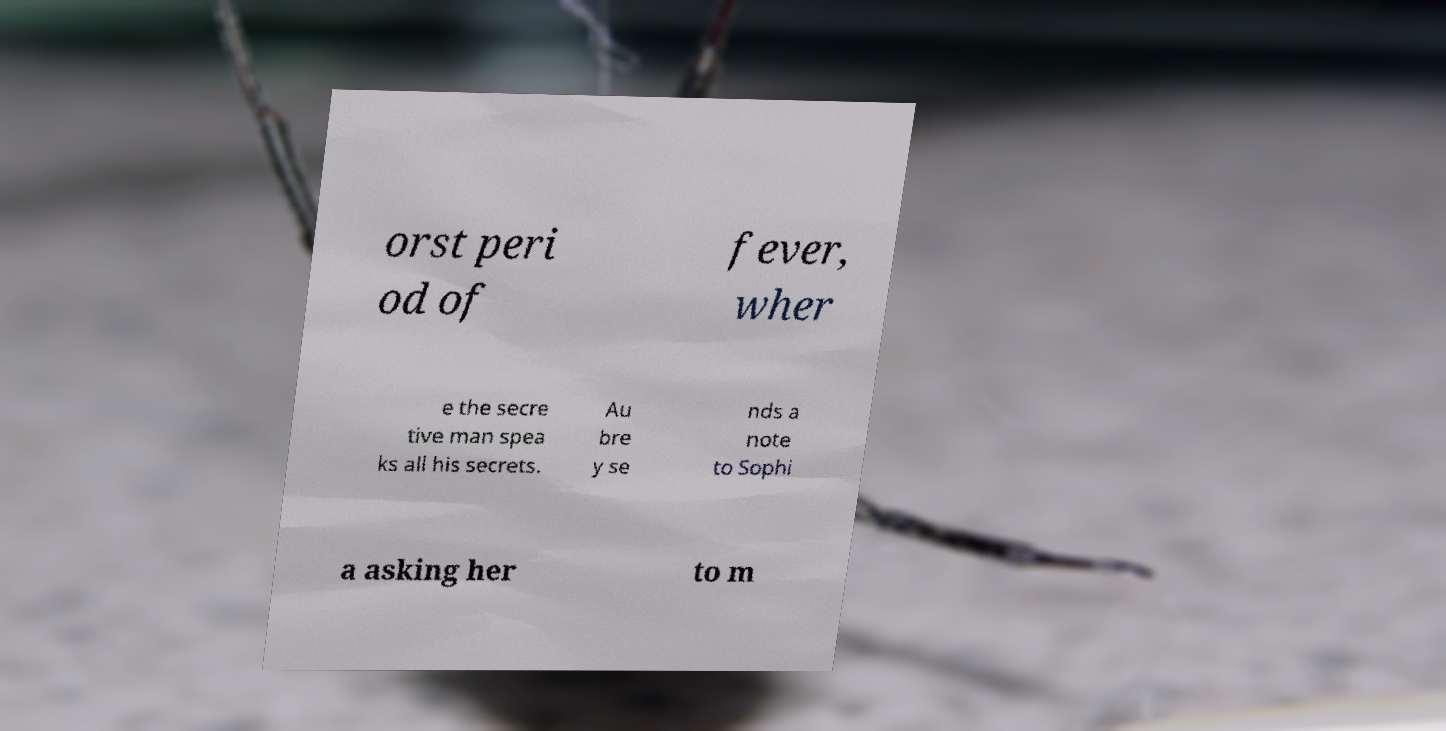Could you assist in decoding the text presented in this image and type it out clearly? orst peri od of fever, wher e the secre tive man spea ks all his secrets. Au bre y se nds a note to Sophi a asking her to m 